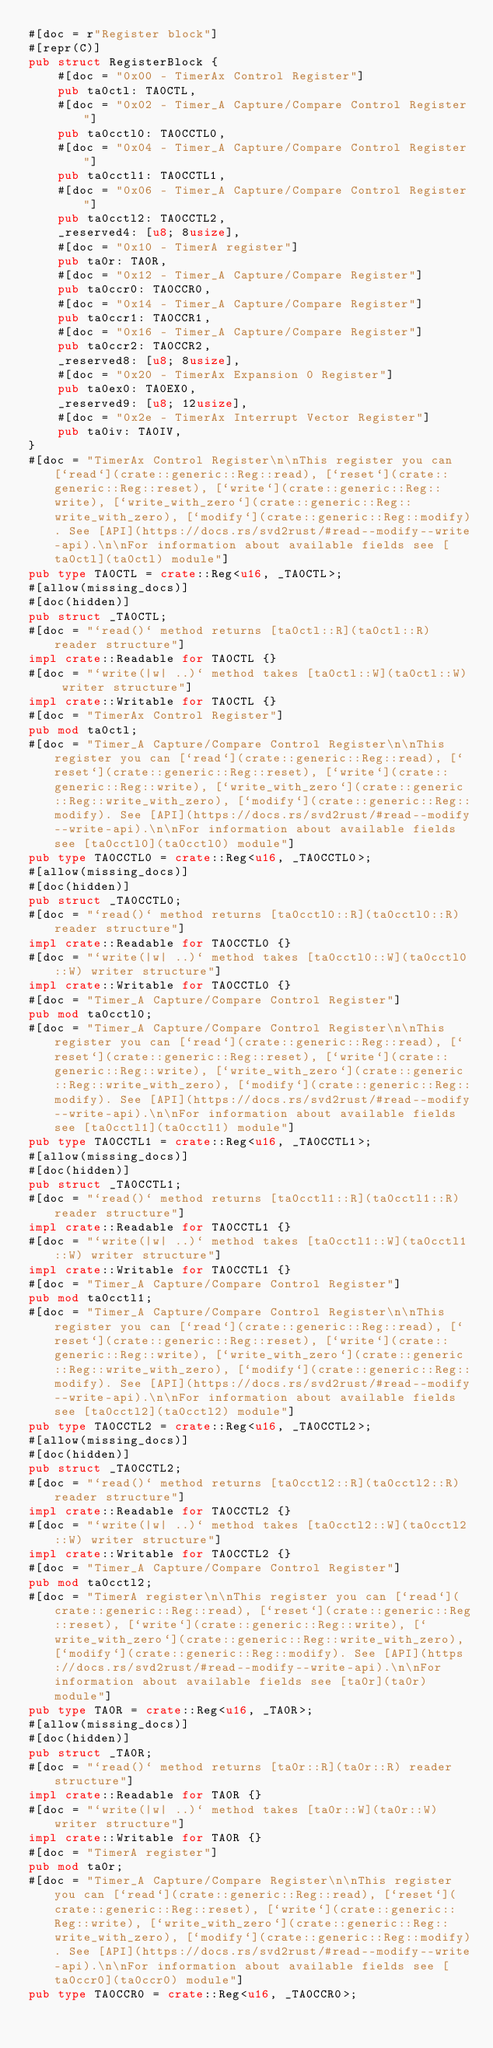<code> <loc_0><loc_0><loc_500><loc_500><_Rust_>#[doc = r"Register block"]
#[repr(C)]
pub struct RegisterBlock {
    #[doc = "0x00 - TimerAx Control Register"]
    pub ta0ctl: TA0CTL,
    #[doc = "0x02 - Timer_A Capture/Compare Control Register"]
    pub ta0cctl0: TA0CCTL0,
    #[doc = "0x04 - Timer_A Capture/Compare Control Register"]
    pub ta0cctl1: TA0CCTL1,
    #[doc = "0x06 - Timer_A Capture/Compare Control Register"]
    pub ta0cctl2: TA0CCTL2,
    _reserved4: [u8; 8usize],
    #[doc = "0x10 - TimerA register"]
    pub ta0r: TA0R,
    #[doc = "0x12 - Timer_A Capture/Compare Register"]
    pub ta0ccr0: TA0CCR0,
    #[doc = "0x14 - Timer_A Capture/Compare Register"]
    pub ta0ccr1: TA0CCR1,
    #[doc = "0x16 - Timer_A Capture/Compare Register"]
    pub ta0ccr2: TA0CCR2,
    _reserved8: [u8; 8usize],
    #[doc = "0x20 - TimerAx Expansion 0 Register"]
    pub ta0ex0: TA0EX0,
    _reserved9: [u8; 12usize],
    #[doc = "0x2e - TimerAx Interrupt Vector Register"]
    pub ta0iv: TA0IV,
}
#[doc = "TimerAx Control Register\n\nThis register you can [`read`](crate::generic::Reg::read), [`reset`](crate::generic::Reg::reset), [`write`](crate::generic::Reg::write), [`write_with_zero`](crate::generic::Reg::write_with_zero), [`modify`](crate::generic::Reg::modify). See [API](https://docs.rs/svd2rust/#read--modify--write-api).\n\nFor information about available fields see [ta0ctl](ta0ctl) module"]
pub type TA0CTL = crate::Reg<u16, _TA0CTL>;
#[allow(missing_docs)]
#[doc(hidden)]
pub struct _TA0CTL;
#[doc = "`read()` method returns [ta0ctl::R](ta0ctl::R) reader structure"]
impl crate::Readable for TA0CTL {}
#[doc = "`write(|w| ..)` method takes [ta0ctl::W](ta0ctl::W) writer structure"]
impl crate::Writable for TA0CTL {}
#[doc = "TimerAx Control Register"]
pub mod ta0ctl;
#[doc = "Timer_A Capture/Compare Control Register\n\nThis register you can [`read`](crate::generic::Reg::read), [`reset`](crate::generic::Reg::reset), [`write`](crate::generic::Reg::write), [`write_with_zero`](crate::generic::Reg::write_with_zero), [`modify`](crate::generic::Reg::modify). See [API](https://docs.rs/svd2rust/#read--modify--write-api).\n\nFor information about available fields see [ta0cctl0](ta0cctl0) module"]
pub type TA0CCTL0 = crate::Reg<u16, _TA0CCTL0>;
#[allow(missing_docs)]
#[doc(hidden)]
pub struct _TA0CCTL0;
#[doc = "`read()` method returns [ta0cctl0::R](ta0cctl0::R) reader structure"]
impl crate::Readable for TA0CCTL0 {}
#[doc = "`write(|w| ..)` method takes [ta0cctl0::W](ta0cctl0::W) writer structure"]
impl crate::Writable for TA0CCTL0 {}
#[doc = "Timer_A Capture/Compare Control Register"]
pub mod ta0cctl0;
#[doc = "Timer_A Capture/Compare Control Register\n\nThis register you can [`read`](crate::generic::Reg::read), [`reset`](crate::generic::Reg::reset), [`write`](crate::generic::Reg::write), [`write_with_zero`](crate::generic::Reg::write_with_zero), [`modify`](crate::generic::Reg::modify). See [API](https://docs.rs/svd2rust/#read--modify--write-api).\n\nFor information about available fields see [ta0cctl1](ta0cctl1) module"]
pub type TA0CCTL1 = crate::Reg<u16, _TA0CCTL1>;
#[allow(missing_docs)]
#[doc(hidden)]
pub struct _TA0CCTL1;
#[doc = "`read()` method returns [ta0cctl1::R](ta0cctl1::R) reader structure"]
impl crate::Readable for TA0CCTL1 {}
#[doc = "`write(|w| ..)` method takes [ta0cctl1::W](ta0cctl1::W) writer structure"]
impl crate::Writable for TA0CCTL1 {}
#[doc = "Timer_A Capture/Compare Control Register"]
pub mod ta0cctl1;
#[doc = "Timer_A Capture/Compare Control Register\n\nThis register you can [`read`](crate::generic::Reg::read), [`reset`](crate::generic::Reg::reset), [`write`](crate::generic::Reg::write), [`write_with_zero`](crate::generic::Reg::write_with_zero), [`modify`](crate::generic::Reg::modify). See [API](https://docs.rs/svd2rust/#read--modify--write-api).\n\nFor information about available fields see [ta0cctl2](ta0cctl2) module"]
pub type TA0CCTL2 = crate::Reg<u16, _TA0CCTL2>;
#[allow(missing_docs)]
#[doc(hidden)]
pub struct _TA0CCTL2;
#[doc = "`read()` method returns [ta0cctl2::R](ta0cctl2::R) reader structure"]
impl crate::Readable for TA0CCTL2 {}
#[doc = "`write(|w| ..)` method takes [ta0cctl2::W](ta0cctl2::W) writer structure"]
impl crate::Writable for TA0CCTL2 {}
#[doc = "Timer_A Capture/Compare Control Register"]
pub mod ta0cctl2;
#[doc = "TimerA register\n\nThis register you can [`read`](crate::generic::Reg::read), [`reset`](crate::generic::Reg::reset), [`write`](crate::generic::Reg::write), [`write_with_zero`](crate::generic::Reg::write_with_zero), [`modify`](crate::generic::Reg::modify). See [API](https://docs.rs/svd2rust/#read--modify--write-api).\n\nFor information about available fields see [ta0r](ta0r) module"]
pub type TA0R = crate::Reg<u16, _TA0R>;
#[allow(missing_docs)]
#[doc(hidden)]
pub struct _TA0R;
#[doc = "`read()` method returns [ta0r::R](ta0r::R) reader structure"]
impl crate::Readable for TA0R {}
#[doc = "`write(|w| ..)` method takes [ta0r::W](ta0r::W) writer structure"]
impl crate::Writable for TA0R {}
#[doc = "TimerA register"]
pub mod ta0r;
#[doc = "Timer_A Capture/Compare Register\n\nThis register you can [`read`](crate::generic::Reg::read), [`reset`](crate::generic::Reg::reset), [`write`](crate::generic::Reg::write), [`write_with_zero`](crate::generic::Reg::write_with_zero), [`modify`](crate::generic::Reg::modify). See [API](https://docs.rs/svd2rust/#read--modify--write-api).\n\nFor information about available fields see [ta0ccr0](ta0ccr0) module"]
pub type TA0CCR0 = crate::Reg<u16, _TA0CCR0>;</code> 